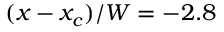Convert formula to latex. <formula><loc_0><loc_0><loc_500><loc_500>( x - x _ { c } ) / W = - 2 . 8</formula> 